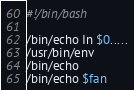Convert code to text. <code><loc_0><loc_0><loc_500><loc_500><_Bash_>#!/bin/bash

/bin/echo In $0.....
/usr/bin/env
/bin/echo
/bin/echo $fan
</code> 